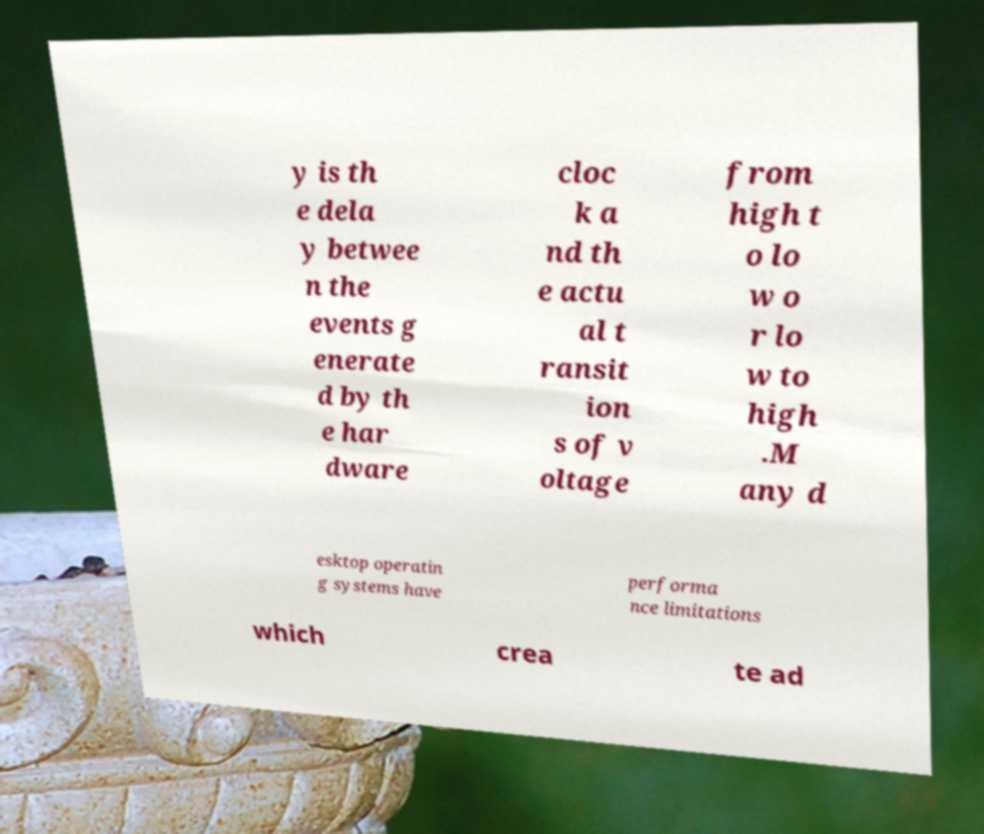Can you read and provide the text displayed in the image?This photo seems to have some interesting text. Can you extract and type it out for me? y is th e dela y betwee n the events g enerate d by th e har dware cloc k a nd th e actu al t ransit ion s of v oltage from high t o lo w o r lo w to high .M any d esktop operatin g systems have performa nce limitations which crea te ad 